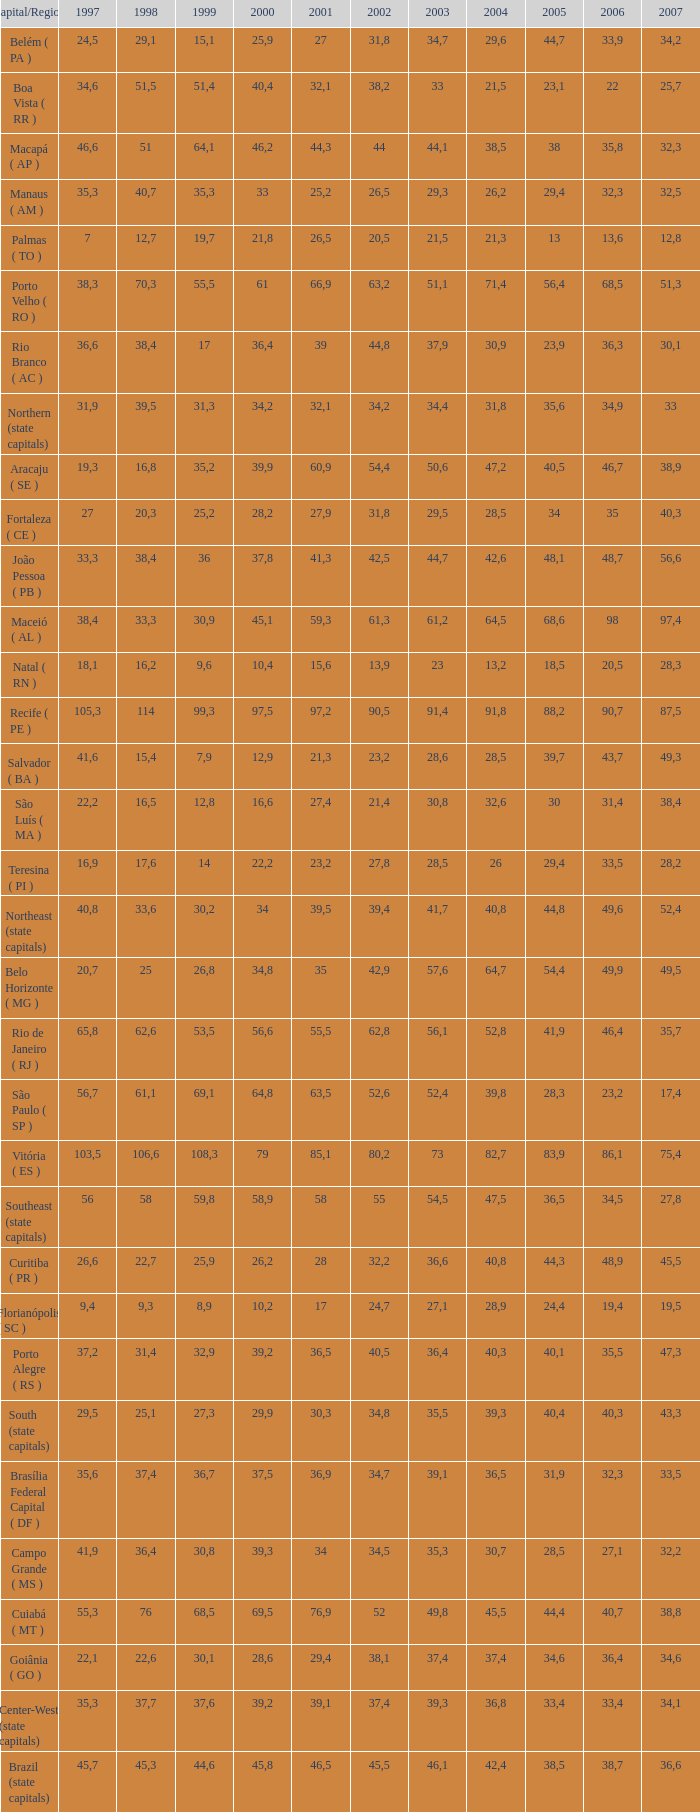What is the typical 2000 value when 1997 is more than 34.6, 2006 is more than 38.7, and 2998 is less than 76? 41.92. 